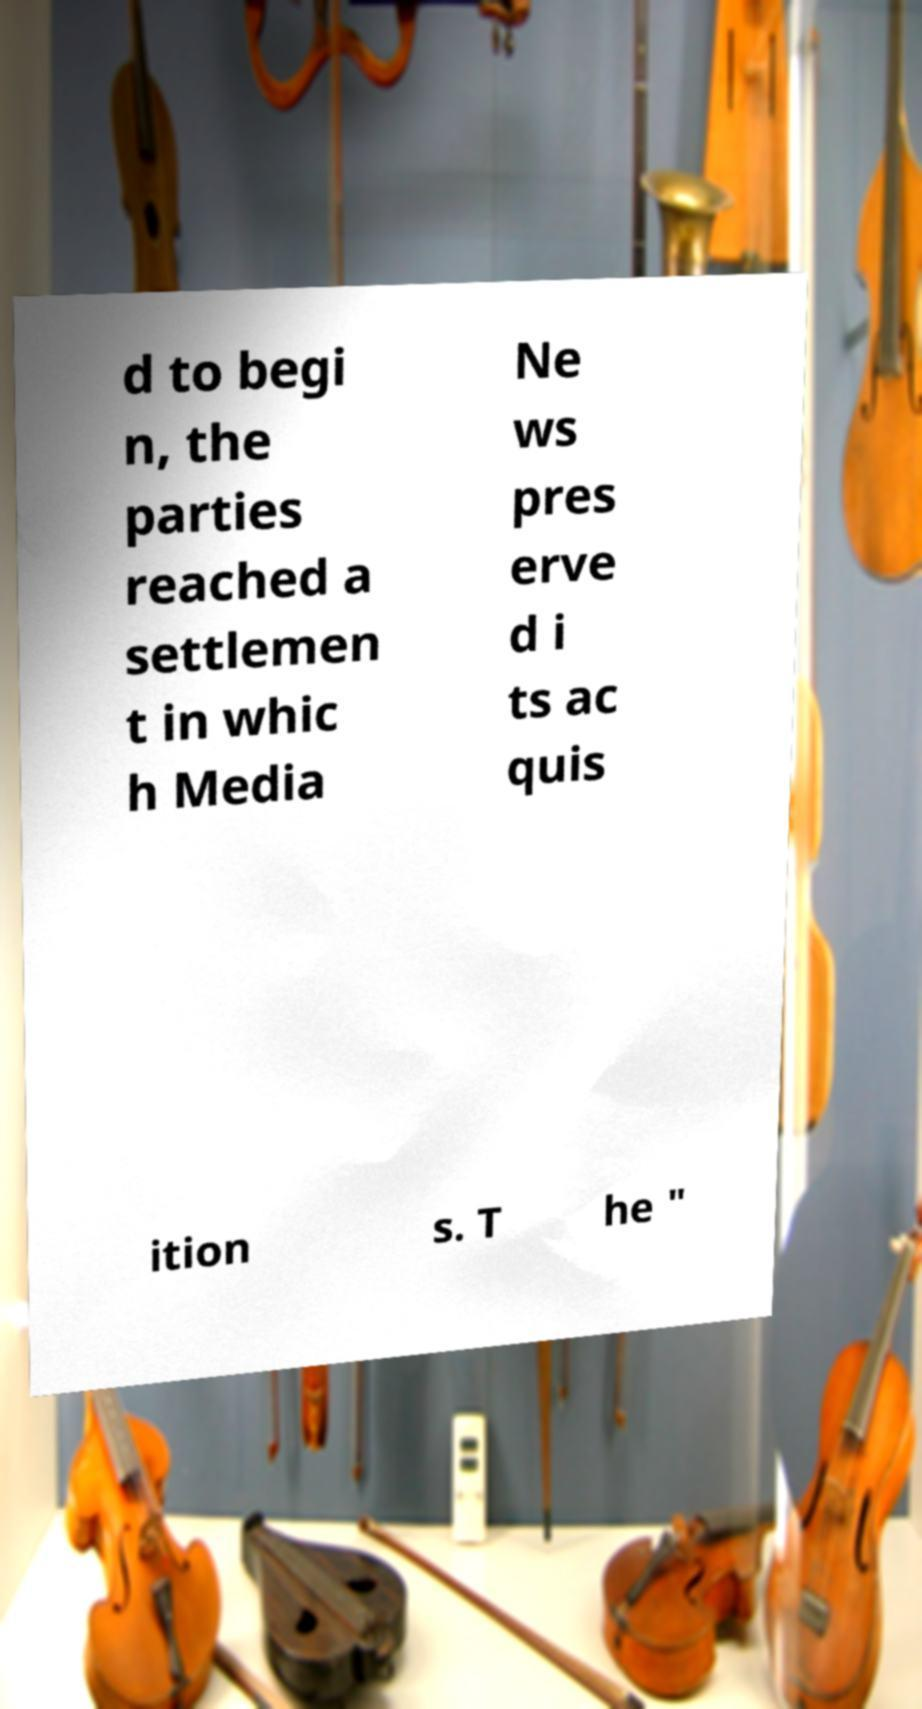For documentation purposes, I need the text within this image transcribed. Could you provide that? d to begi n, the parties reached a settlemen t in whic h Media Ne ws pres erve d i ts ac quis ition s. T he " 